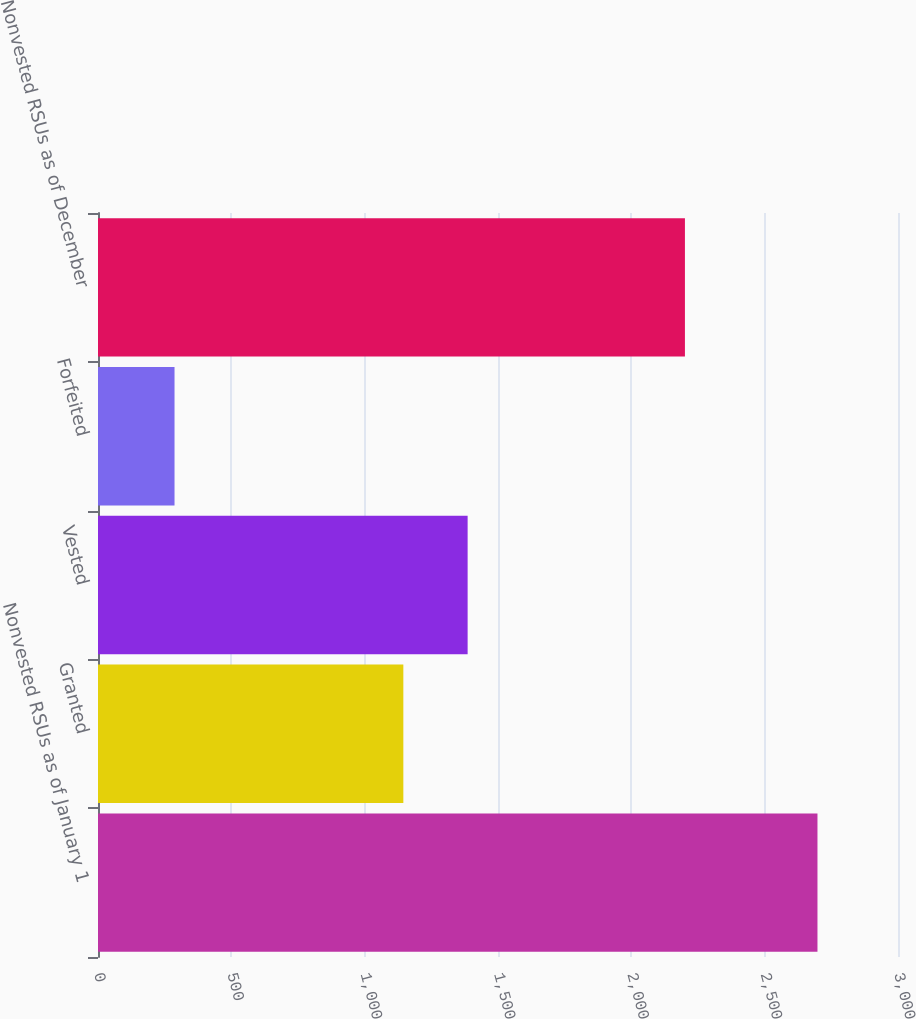Convert chart to OTSL. <chart><loc_0><loc_0><loc_500><loc_500><bar_chart><fcel>Nonvested RSUs as of January 1<fcel>Granted<fcel>Vested<fcel>Forfeited<fcel>Nonvested RSUs as of December<nl><fcel>2698<fcel>1145<fcel>1386.1<fcel>287<fcel>2201<nl></chart> 